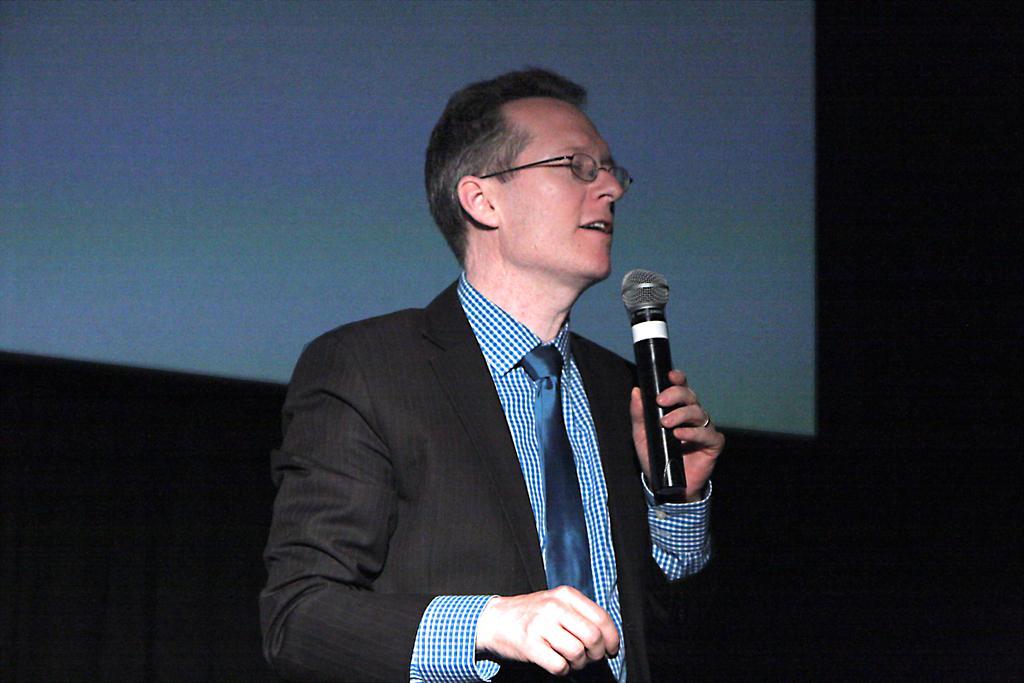In one or two sentences, can you explain what this image depicts? In this Image I see a man who is holding a mic. 